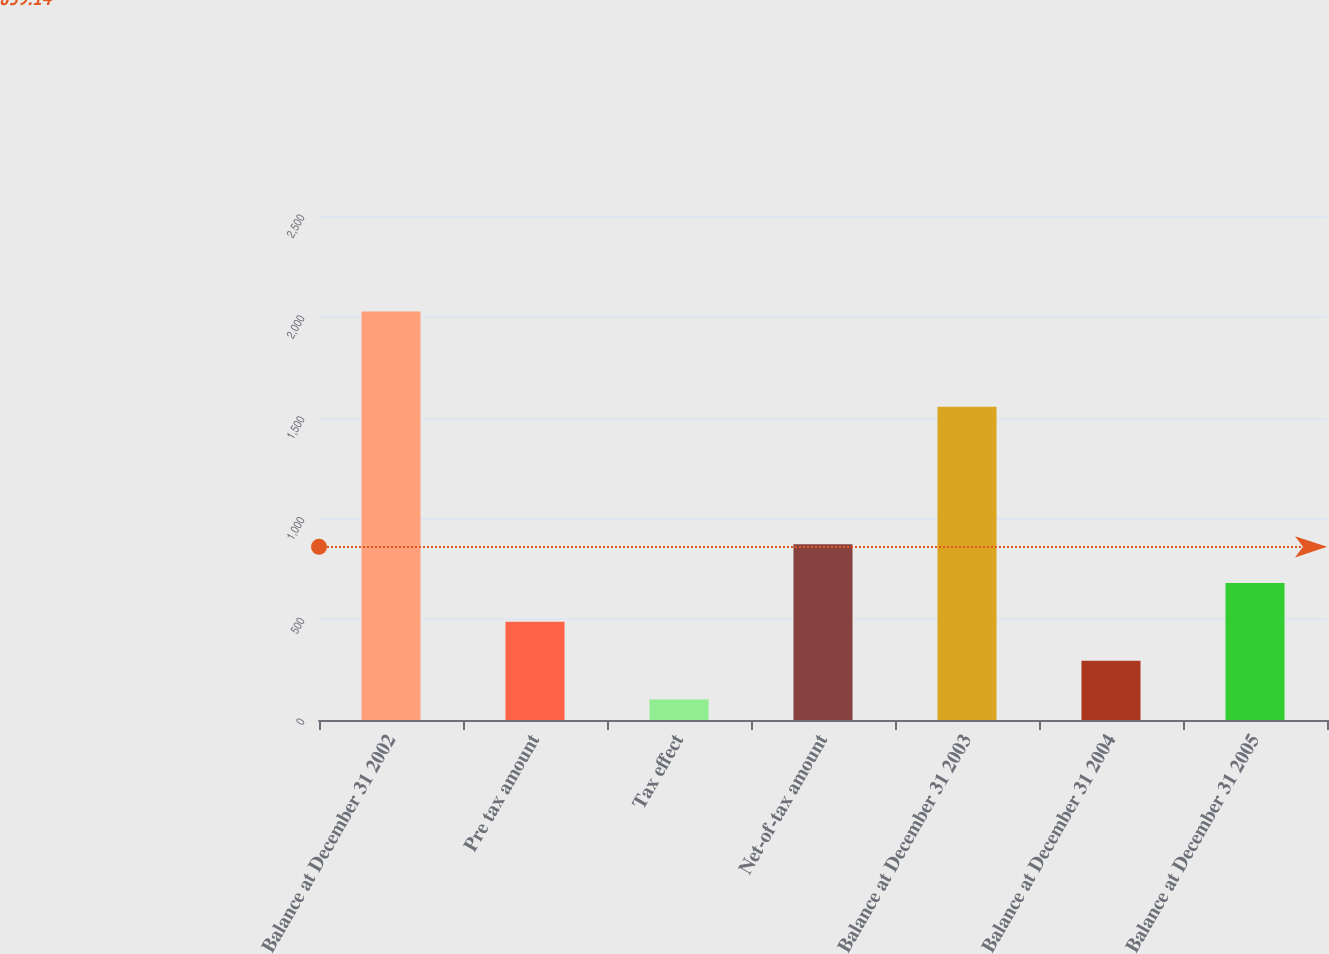Convert chart to OTSL. <chart><loc_0><loc_0><loc_500><loc_500><bar_chart><fcel>Balance at December 31 2002<fcel>Pre tax amount<fcel>Tax effect<fcel>Net-of-tax amount<fcel>Balance at December 31 2003<fcel>Balance at December 31 2004<fcel>Balance at December 31 2005<nl><fcel>2026<fcel>486.8<fcel>102<fcel>871.6<fcel>1554<fcel>294.4<fcel>679.2<nl></chart> 